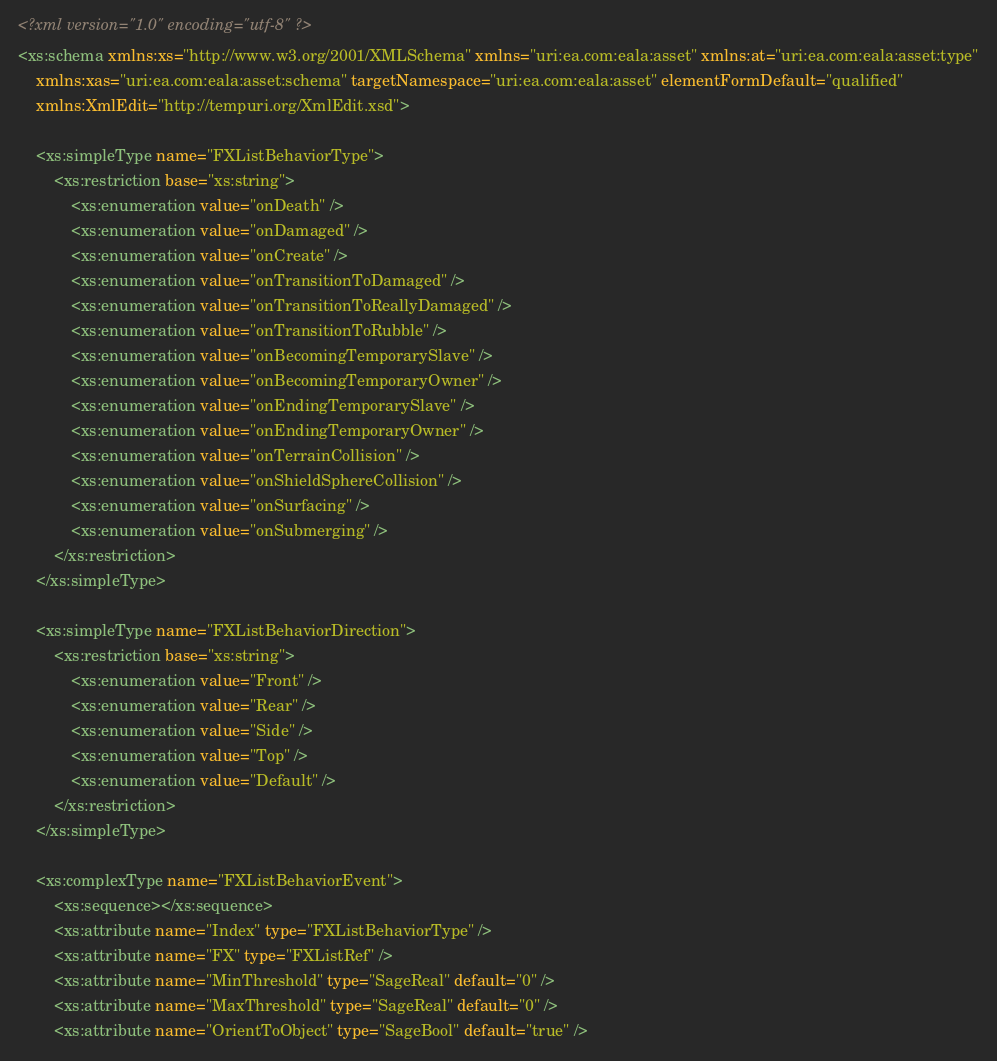<code> <loc_0><loc_0><loc_500><loc_500><_XML_><?xml version="1.0" encoding="utf-8" ?>
<xs:schema xmlns:xs="http://www.w3.org/2001/XMLSchema" xmlns="uri:ea.com:eala:asset" xmlns:at="uri:ea.com:eala:asset:type"
	xmlns:xas="uri:ea.com:eala:asset:schema" targetNamespace="uri:ea.com:eala:asset" elementFormDefault="qualified"
	xmlns:XmlEdit="http://tempuri.org/XmlEdit.xsd">
	
	<xs:simpleType name="FXListBehaviorType">
		<xs:restriction base="xs:string">
			<xs:enumeration value="onDeath" />
			<xs:enumeration value="onDamaged" />
			<xs:enumeration value="onCreate" />
			<xs:enumeration value="onTransitionToDamaged" />
			<xs:enumeration value="onTransitionToReallyDamaged" />
			<xs:enumeration value="onTransitionToRubble" />
			<xs:enumeration value="onBecomingTemporarySlave" />
			<xs:enumeration value="onBecomingTemporaryOwner" />
			<xs:enumeration value="onEndingTemporarySlave" />
			<xs:enumeration value="onEndingTemporaryOwner" />
			<xs:enumeration value="onTerrainCollision" />
			<xs:enumeration value="onShieldSphereCollision" />
			<xs:enumeration value="onSurfacing" />
			<xs:enumeration value="onSubmerging" />
		</xs:restriction>
	</xs:simpleType>
	
	<xs:simpleType name="FXListBehaviorDirection">
		<xs:restriction base="xs:string">
			<xs:enumeration value="Front" />
			<xs:enumeration value="Rear" />
			<xs:enumeration value="Side" />
			<xs:enumeration value="Top" />
			<xs:enumeration value="Default" />
		</xs:restriction>
	</xs:simpleType>
	
	<xs:complexType name="FXListBehaviorEvent">
		<xs:sequence></xs:sequence>
		<xs:attribute name="Index" type="FXListBehaviorType" />
		<xs:attribute name="FX" type="FXListRef" />
		<xs:attribute name="MinThreshold" type="SageReal" default="0" />
		<xs:attribute name="MaxThreshold" type="SageReal" default="0" />
		<xs:attribute name="OrientToObject" type="SageBool" default="true" /></code> 